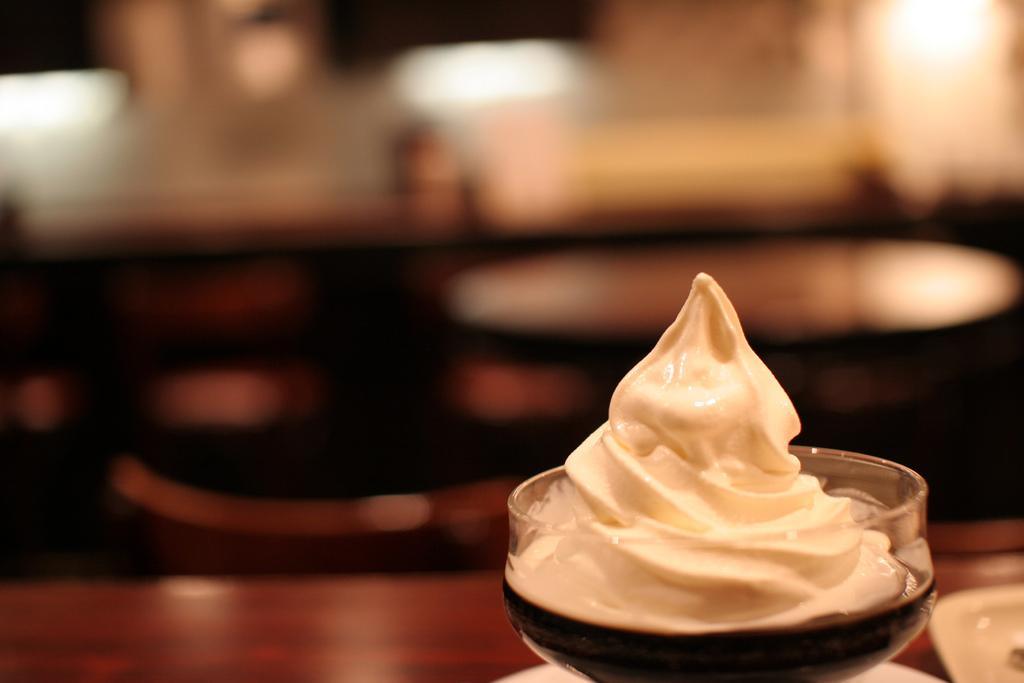What is the main subject of the image? The main subject of the image is an ice cream. How is the ice cream contained in the image? The ice cream is in a glass. What else can be seen on the table in the image? There are other objects on the table in the image. Can you describe the background of the image? The background of the image is blurry. What type of team is visible in the image? There is no team present in the image; it features an ice cream in a glass on a table with a blurry background. What type of brass instrument can be heard playing in the image? There is no brass instrument or sound present in the image; it is a still image of an ice cream in a glass on a table with a blurry background. 